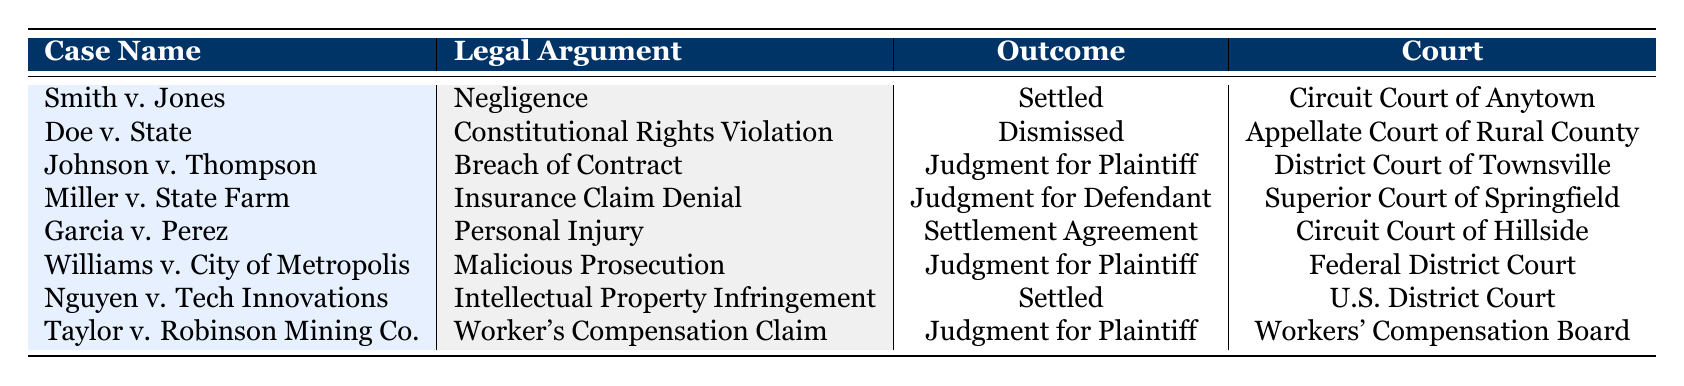What is the outcome of "Smith v. Jones"? The table indicates that the outcome of "Smith v. Jones" is "Settled."
Answer: Settled How many cases resulted in a judgment for the plaintiff? A review of the table shows that "Johnson v. Thompson", "Williams v. City of Metropolis", and "Taylor v. Robinson Mining Co." all resulted in a judgment for the plaintiff, totaling 3 cases.
Answer: 3 Did "Doe v. State" result in a settlement? The table states that the outcome for "Doe v. State" is "Dismissed", not a settlement.
Answer: No Which case involving an insurance claim was decided in favor of the defendant? According to the table, "Miller v. State Farm" is the case related to an insurance claim and the outcome was "Judgment for Defendant."
Answer: Miller v. State Farm How many different legal arguments were presented in the cases listed? The table lists 8 different legal arguments, as seen in the unique entries under the Legal Argument column.
Answer: 8 What is the court associated with "Garcia v. Perez"? The table specifies that "Garcia v. Perez" was handled in the "Circuit Court of Hillside."
Answer: Circuit Court of Hillside Are there any cases that were settled? The table shows "Smith v. Jones," "Nguyen v. Tech Innovations," and "Garcia v. Perez" as settled cases, indicating there are cases that were settled.
Answer: Yes Which legal argument had the highest number of outcomes in favor of the plaintiff? By analyzing the outcomes, the legal arguments of "Breach of Contract," "Malicious Prosecution," and "Worker's Compensation Claim" each resulted in a judgment for the plaintiff. Therefore, there are three arguments tied for this status.
Answer: 3 arguments (Breach of Contract, Malicious Prosecution, Worker's Compensation Claim) 